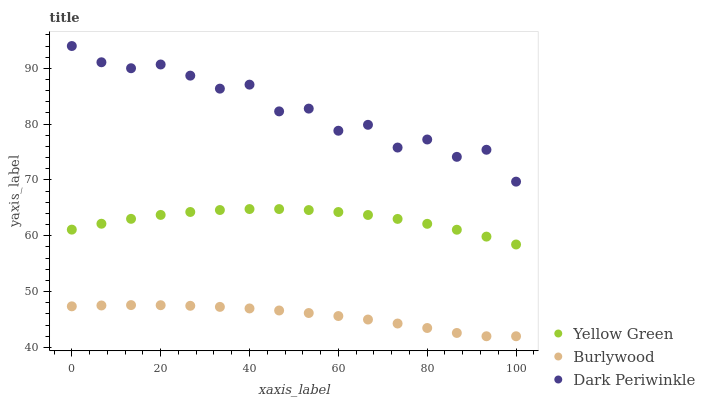Does Burlywood have the minimum area under the curve?
Answer yes or no. Yes. Does Dark Periwinkle have the maximum area under the curve?
Answer yes or no. Yes. Does Yellow Green have the minimum area under the curve?
Answer yes or no. No. Does Yellow Green have the maximum area under the curve?
Answer yes or no. No. Is Burlywood the smoothest?
Answer yes or no. Yes. Is Dark Periwinkle the roughest?
Answer yes or no. Yes. Is Yellow Green the smoothest?
Answer yes or no. No. Is Yellow Green the roughest?
Answer yes or no. No. Does Burlywood have the lowest value?
Answer yes or no. Yes. Does Yellow Green have the lowest value?
Answer yes or no. No. Does Dark Periwinkle have the highest value?
Answer yes or no. Yes. Does Yellow Green have the highest value?
Answer yes or no. No. Is Burlywood less than Dark Periwinkle?
Answer yes or no. Yes. Is Dark Periwinkle greater than Burlywood?
Answer yes or no. Yes. Does Burlywood intersect Dark Periwinkle?
Answer yes or no. No. 